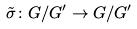Convert formula to latex. <formula><loc_0><loc_0><loc_500><loc_500>\tilde { \sigma } \colon G / G ^ { \prime } \rightarrow G / G ^ { \prime }</formula> 